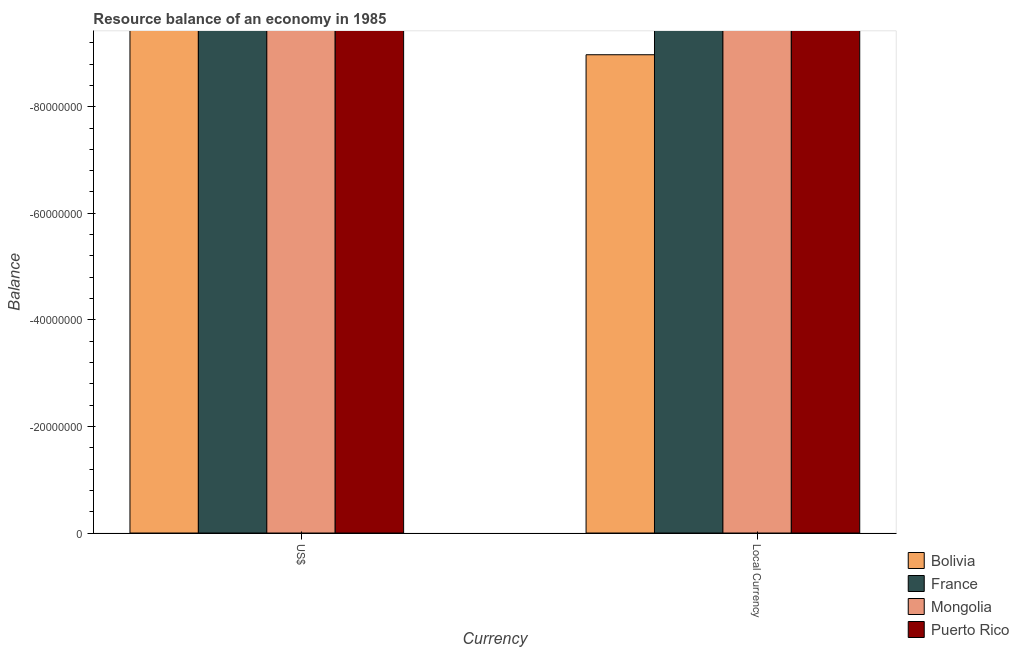Are the number of bars on each tick of the X-axis equal?
Make the answer very short. Yes. How many bars are there on the 1st tick from the right?
Your answer should be very brief. 0. What is the label of the 1st group of bars from the left?
Your response must be concise. US$. Across all countries, what is the minimum resource balance in constant us$?
Offer a very short reply. 0. What is the total resource balance in us$ in the graph?
Your response must be concise. 0. What is the difference between the resource balance in constant us$ in Bolivia and the resource balance in us$ in Mongolia?
Your answer should be very brief. 0. What is the average resource balance in constant us$ per country?
Your answer should be very brief. 0. How many bars are there?
Provide a short and direct response. 0. What is the difference between two consecutive major ticks on the Y-axis?
Make the answer very short. 2.00e+07. Are the values on the major ticks of Y-axis written in scientific E-notation?
Offer a terse response. No. Does the graph contain any zero values?
Provide a short and direct response. Yes. How are the legend labels stacked?
Keep it short and to the point. Vertical. What is the title of the graph?
Give a very brief answer. Resource balance of an economy in 1985. What is the label or title of the X-axis?
Give a very brief answer. Currency. What is the label or title of the Y-axis?
Provide a succinct answer. Balance. What is the Balance of Mongolia in US$?
Keep it short and to the point. 0. What is the Balance of France in Local Currency?
Your answer should be compact. 0. What is the Balance in Puerto Rico in Local Currency?
Give a very brief answer. 0. What is the total Balance in France in the graph?
Your answer should be compact. 0. What is the total Balance in Puerto Rico in the graph?
Your answer should be very brief. 0. What is the average Balance in Bolivia per Currency?
Provide a short and direct response. 0. What is the average Balance of France per Currency?
Offer a very short reply. 0. What is the average Balance of Mongolia per Currency?
Your answer should be very brief. 0. 